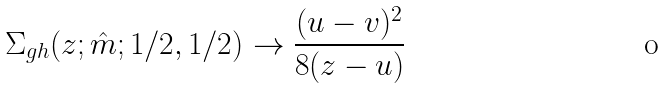<formula> <loc_0><loc_0><loc_500><loc_500>\Sigma _ { g h } ( z ; \hat { m } ; 1 / 2 , 1 / 2 ) \to \frac { ( u - v ) ^ { 2 } } { 8 ( z - u ) }</formula> 